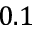<formula> <loc_0><loc_0><loc_500><loc_500>0 . 1</formula> 